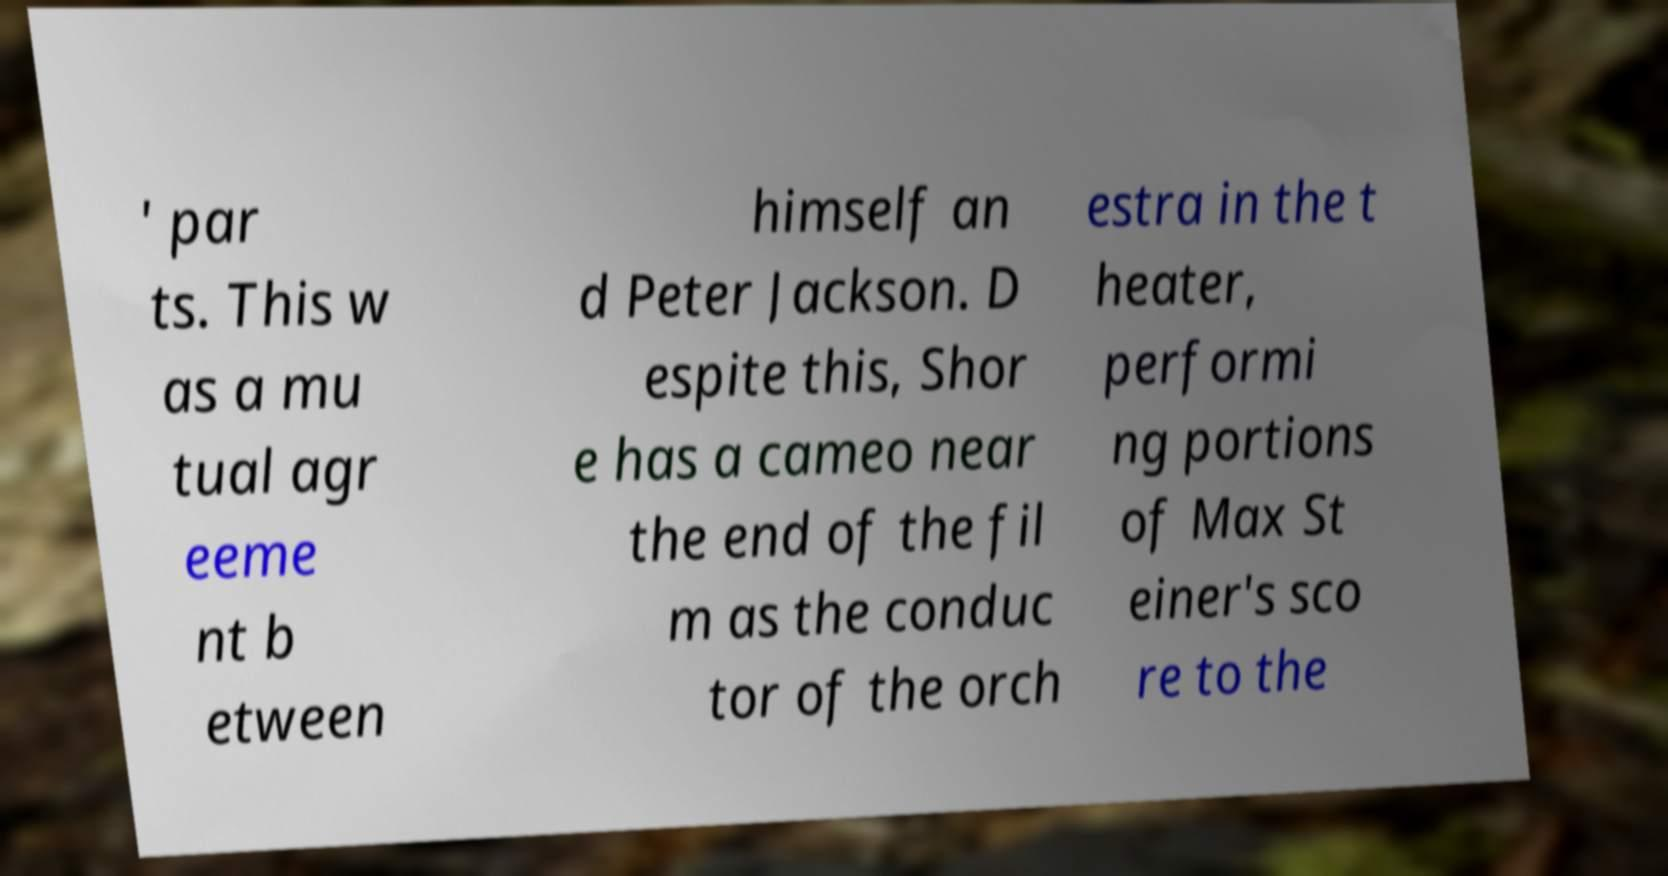Could you assist in decoding the text presented in this image and type it out clearly? ' par ts. This w as a mu tual agr eeme nt b etween himself an d Peter Jackson. D espite this, Shor e has a cameo near the end of the fil m as the conduc tor of the orch estra in the t heater, performi ng portions of Max St einer's sco re to the 